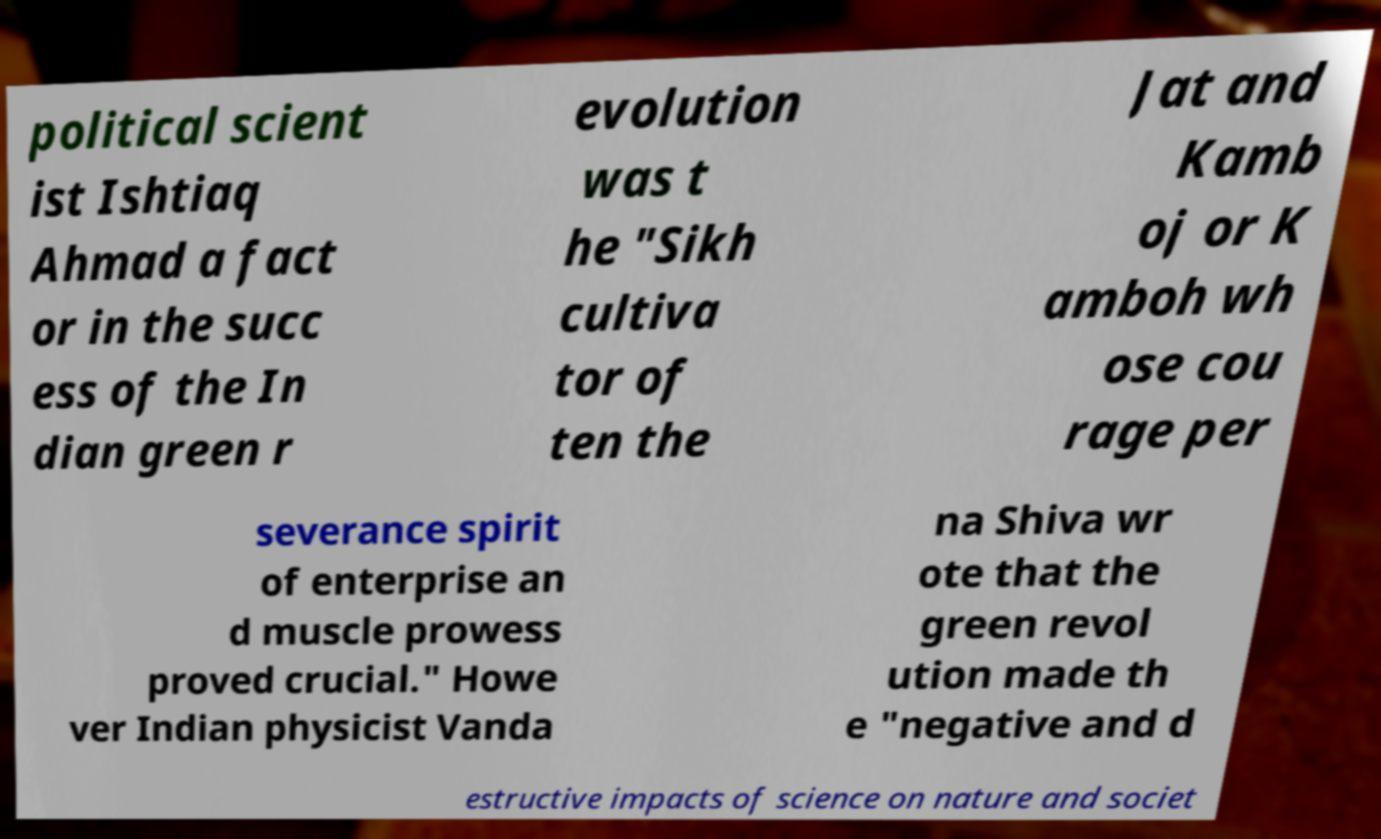Could you assist in decoding the text presented in this image and type it out clearly? political scient ist Ishtiaq Ahmad a fact or in the succ ess of the In dian green r evolution was t he "Sikh cultiva tor of ten the Jat and Kamb oj or K amboh wh ose cou rage per severance spirit of enterprise an d muscle prowess proved crucial." Howe ver Indian physicist Vanda na Shiva wr ote that the green revol ution made th e "negative and d estructive impacts of science on nature and societ 